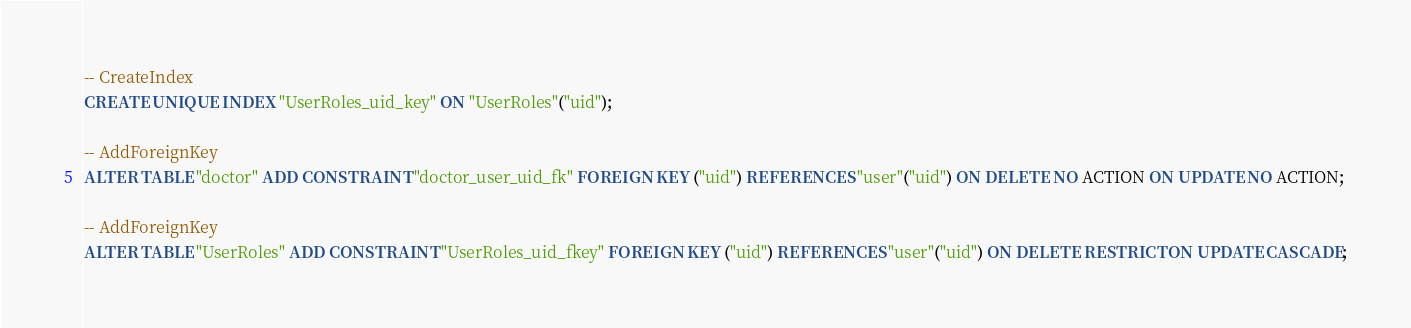Convert code to text. <code><loc_0><loc_0><loc_500><loc_500><_SQL_>
-- CreateIndex
CREATE UNIQUE INDEX "UserRoles_uid_key" ON "UserRoles"("uid");

-- AddForeignKey
ALTER TABLE "doctor" ADD CONSTRAINT "doctor_user_uid_fk" FOREIGN KEY ("uid") REFERENCES "user"("uid") ON DELETE NO ACTION ON UPDATE NO ACTION;

-- AddForeignKey
ALTER TABLE "UserRoles" ADD CONSTRAINT "UserRoles_uid_fkey" FOREIGN KEY ("uid") REFERENCES "user"("uid") ON DELETE RESTRICT ON UPDATE CASCADE;
</code> 